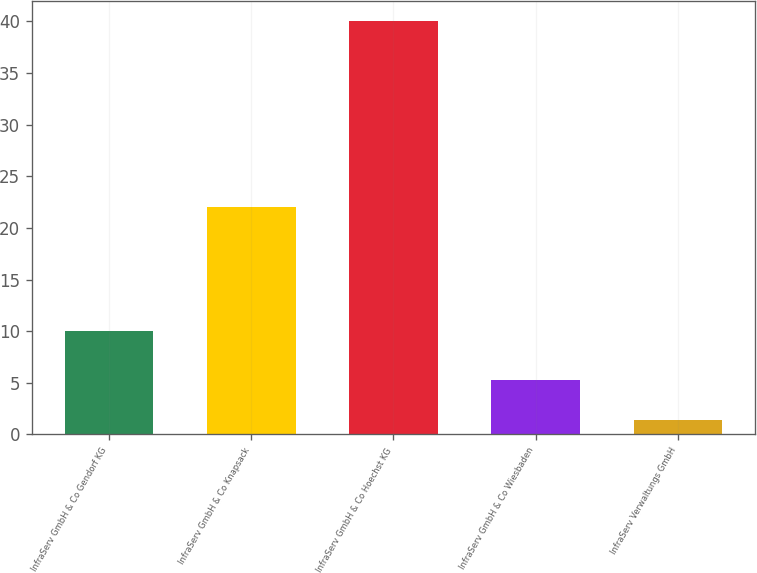<chart> <loc_0><loc_0><loc_500><loc_500><bar_chart><fcel>InfraServ GmbH & Co Gendorf KG<fcel>InfraServ GmbH & Co Knapsack<fcel>InfraServ GmbH & Co Hoechst KG<fcel>InfraServ GmbH & Co Wiesbaden<fcel>InfraServ Verwaltungs GmbH<nl><fcel>10<fcel>22<fcel>40<fcel>5.23<fcel>1.37<nl></chart> 